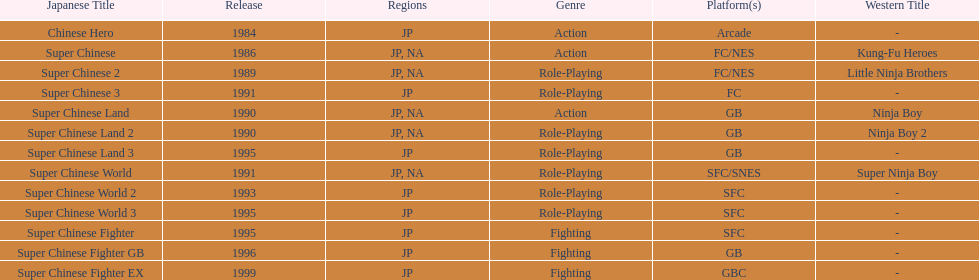Number of super chinese world games released 3. 